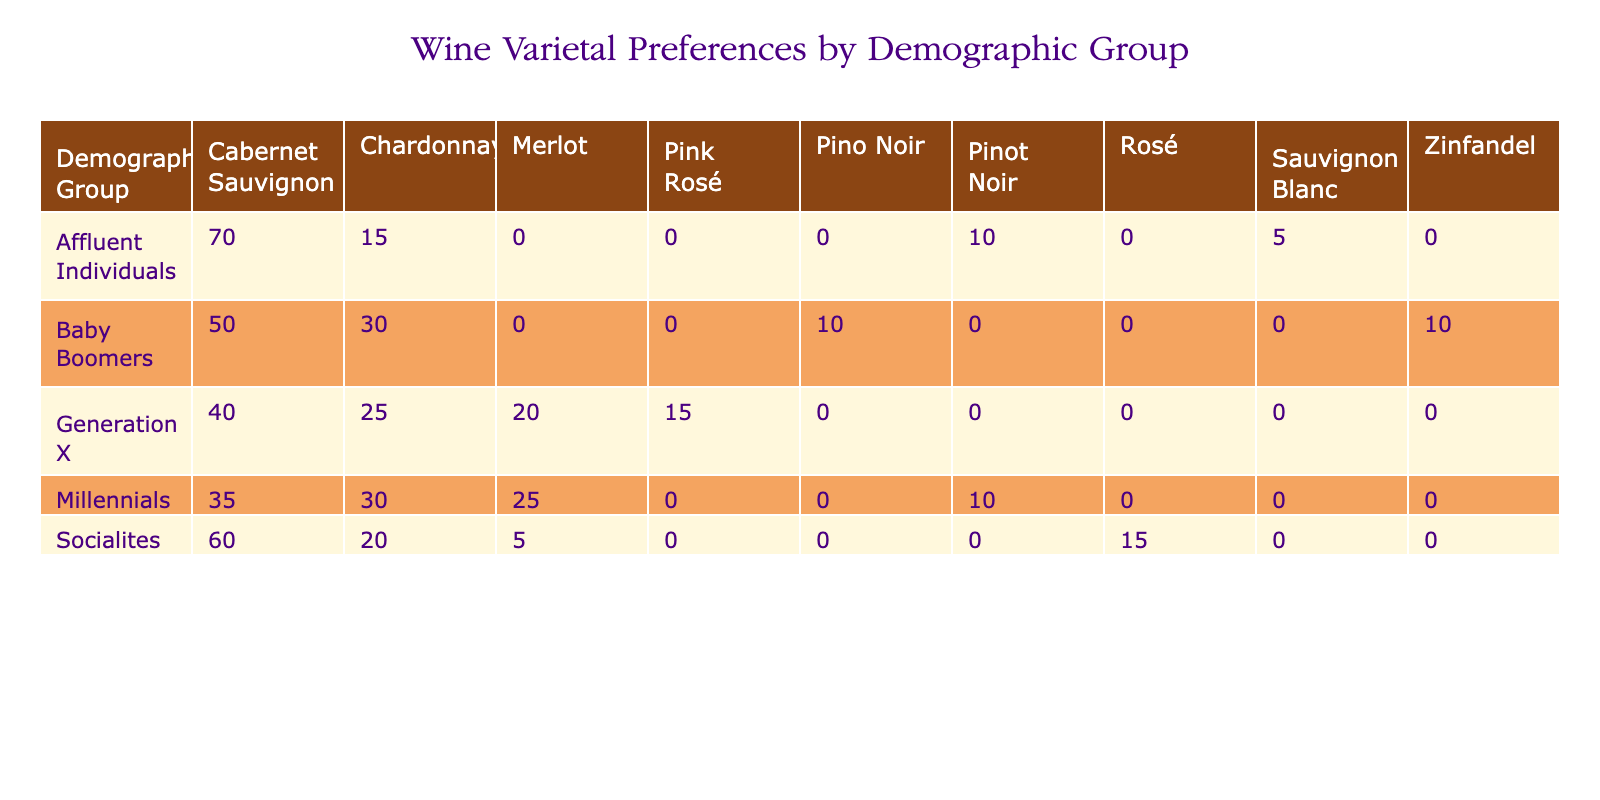What is the preference percentage for Cabernet Sauvignon among Baby Boomers? The table shows the preference percentage for each varietal within each demographic group. Looking at the row for Baby Boomers, the preference percentage for Cabernet Sauvignon is clearly listed as 50%.
Answer: 50% Which varietal is most preferred by Affluent Individuals? By examining the row for Affluent Individuals, we see that Cabernet Sauvignon has the highest preference percentage at 70%.
Answer: Cabernet Sauvignon What is the total preference percentage for Chardonnay across all demographic groups? We need to sum the preference percentages for Chardonnay across the four demographic groups: 30 (Millennials) + 25 (Generation X) + 30 (Baby Boomers) + 15 (Affluent Individuals) + 20 (Socialites) = 120.
Answer: 120 Is the preference for Pinot Noir higher among Millennials than Baby Boomers? The preference for Pinot Noir among Millennials is 10% while for Baby Boomers it is also 10%. Since both values are equal, it can be concluded that the preference for Pinot Noir is not higher among Millennials.
Answer: No What is the difference between the preference percentages for Cabernet Sauvignon and Zinfandel among Baby Boomers? From the table, Baby Boomers have a preference of 50% for Cabernet Sauvignon and 10% for Zinfandel. The difference would be 50% - 10% = 40%.
Answer: 40% Which demographic group has the highest total preference percentage for Rosé? Looking through the table, Rosé is preferred only by Socialites with a preference percentage of 15%. Thus, Socialites hold the highest percentage for Rosé as it is the only group listed for this varietal.
Answer: Socialites What is the average preference percentage for Merlot across all demographic groups? The preference percentages for Merlot are: 25 (Millennials) + 20 (Generation X) + 5 (Socialites). There are 3 data points, and the sum is 50. Therefore, the average is 50 / 3 = 16.67.
Answer: 16.67 Does any demographic group have a preference percentage for Sauvignon Blanc? The preference percentage for Sauvignon Blanc from the table shows that only Affluent Individuals have a preference of 5%. Thus, yes, there is a demographic group with a preference for Sauvignon Blanc.
Answer: Yes Are Millennials more likely to prefer Pinot Noir than Generation X? Millennials have a preference of 10% for Pinot Noir, and Generation X's preference is not stated for this varietal, implying it could be 0%. This means Millennials are indeed more likely to prefer it than Generation X.
Answer: Yes 